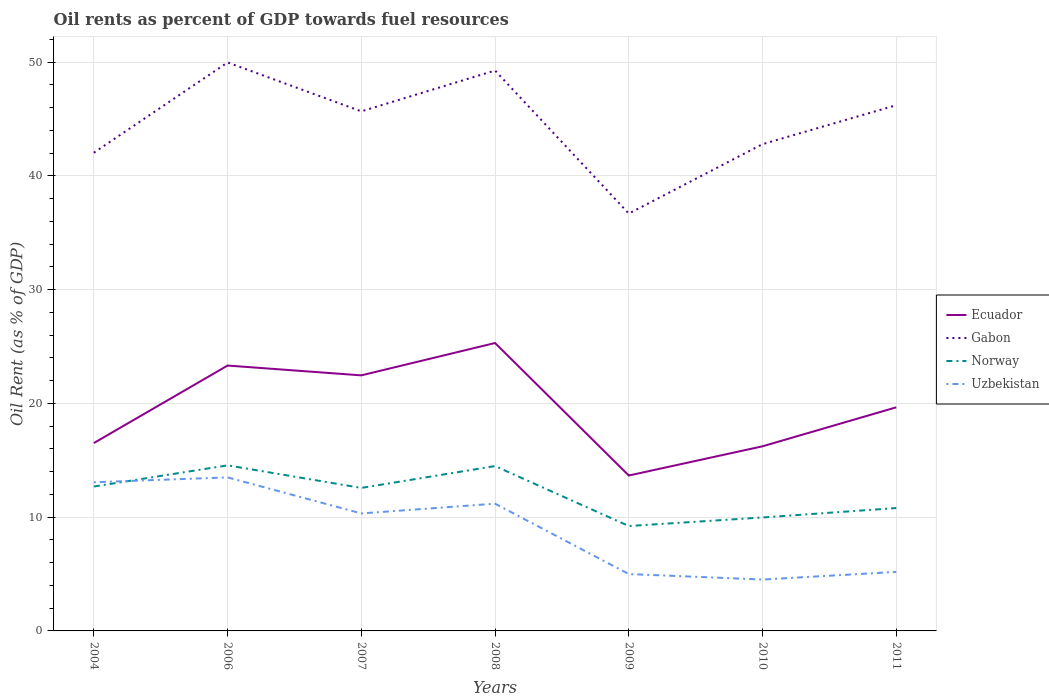Does the line corresponding to Norway intersect with the line corresponding to Uzbekistan?
Keep it short and to the point. Yes. Is the number of lines equal to the number of legend labels?
Ensure brevity in your answer.  Yes. Across all years, what is the maximum oil rent in Gabon?
Keep it short and to the point. 36.69. What is the total oil rent in Norway in the graph?
Provide a short and direct response. 0.12. What is the difference between the highest and the second highest oil rent in Ecuador?
Your answer should be compact. 11.65. How many years are there in the graph?
Your answer should be compact. 7. Does the graph contain any zero values?
Your answer should be compact. No. How many legend labels are there?
Provide a succinct answer. 4. What is the title of the graph?
Give a very brief answer. Oil rents as percent of GDP towards fuel resources. What is the label or title of the Y-axis?
Your response must be concise. Oil Rent (as % of GDP). What is the Oil Rent (as % of GDP) of Ecuador in 2004?
Provide a succinct answer. 16.51. What is the Oil Rent (as % of GDP) of Gabon in 2004?
Your answer should be compact. 42.04. What is the Oil Rent (as % of GDP) in Norway in 2004?
Offer a very short reply. 12.69. What is the Oil Rent (as % of GDP) in Uzbekistan in 2004?
Your answer should be very brief. 13.07. What is the Oil Rent (as % of GDP) of Ecuador in 2006?
Offer a terse response. 23.33. What is the Oil Rent (as % of GDP) of Gabon in 2006?
Ensure brevity in your answer.  49.98. What is the Oil Rent (as % of GDP) of Norway in 2006?
Provide a short and direct response. 14.56. What is the Oil Rent (as % of GDP) of Uzbekistan in 2006?
Provide a succinct answer. 13.5. What is the Oil Rent (as % of GDP) in Ecuador in 2007?
Provide a short and direct response. 22.47. What is the Oil Rent (as % of GDP) in Gabon in 2007?
Your answer should be very brief. 45.68. What is the Oil Rent (as % of GDP) of Norway in 2007?
Make the answer very short. 12.57. What is the Oil Rent (as % of GDP) in Uzbekistan in 2007?
Keep it short and to the point. 10.33. What is the Oil Rent (as % of GDP) of Ecuador in 2008?
Give a very brief answer. 25.31. What is the Oil Rent (as % of GDP) in Gabon in 2008?
Provide a succinct answer. 49.26. What is the Oil Rent (as % of GDP) in Norway in 2008?
Offer a very short reply. 14.49. What is the Oil Rent (as % of GDP) of Uzbekistan in 2008?
Give a very brief answer. 11.19. What is the Oil Rent (as % of GDP) of Ecuador in 2009?
Offer a very short reply. 13.66. What is the Oil Rent (as % of GDP) of Gabon in 2009?
Give a very brief answer. 36.69. What is the Oil Rent (as % of GDP) of Norway in 2009?
Offer a terse response. 9.22. What is the Oil Rent (as % of GDP) of Uzbekistan in 2009?
Your answer should be very brief. 5. What is the Oil Rent (as % of GDP) in Ecuador in 2010?
Give a very brief answer. 16.23. What is the Oil Rent (as % of GDP) of Gabon in 2010?
Provide a short and direct response. 42.79. What is the Oil Rent (as % of GDP) of Norway in 2010?
Make the answer very short. 9.97. What is the Oil Rent (as % of GDP) of Uzbekistan in 2010?
Your response must be concise. 4.52. What is the Oil Rent (as % of GDP) in Ecuador in 2011?
Give a very brief answer. 19.66. What is the Oil Rent (as % of GDP) of Gabon in 2011?
Offer a terse response. 46.22. What is the Oil Rent (as % of GDP) in Norway in 2011?
Offer a terse response. 10.8. What is the Oil Rent (as % of GDP) in Uzbekistan in 2011?
Keep it short and to the point. 5.19. Across all years, what is the maximum Oil Rent (as % of GDP) of Ecuador?
Keep it short and to the point. 25.31. Across all years, what is the maximum Oil Rent (as % of GDP) in Gabon?
Your answer should be very brief. 49.98. Across all years, what is the maximum Oil Rent (as % of GDP) in Norway?
Give a very brief answer. 14.56. Across all years, what is the maximum Oil Rent (as % of GDP) in Uzbekistan?
Your answer should be very brief. 13.5. Across all years, what is the minimum Oil Rent (as % of GDP) of Ecuador?
Provide a succinct answer. 13.66. Across all years, what is the minimum Oil Rent (as % of GDP) of Gabon?
Your answer should be very brief. 36.69. Across all years, what is the minimum Oil Rent (as % of GDP) of Norway?
Offer a very short reply. 9.22. Across all years, what is the minimum Oil Rent (as % of GDP) of Uzbekistan?
Keep it short and to the point. 4.52. What is the total Oil Rent (as % of GDP) in Ecuador in the graph?
Offer a terse response. 137.17. What is the total Oil Rent (as % of GDP) of Gabon in the graph?
Your answer should be very brief. 312.66. What is the total Oil Rent (as % of GDP) in Norway in the graph?
Your answer should be compact. 84.31. What is the total Oil Rent (as % of GDP) of Uzbekistan in the graph?
Ensure brevity in your answer.  62.79. What is the difference between the Oil Rent (as % of GDP) of Ecuador in 2004 and that in 2006?
Ensure brevity in your answer.  -6.82. What is the difference between the Oil Rent (as % of GDP) in Gabon in 2004 and that in 2006?
Make the answer very short. -7.94. What is the difference between the Oil Rent (as % of GDP) of Norway in 2004 and that in 2006?
Provide a succinct answer. -1.86. What is the difference between the Oil Rent (as % of GDP) of Uzbekistan in 2004 and that in 2006?
Offer a terse response. -0.43. What is the difference between the Oil Rent (as % of GDP) of Ecuador in 2004 and that in 2007?
Provide a short and direct response. -5.95. What is the difference between the Oil Rent (as % of GDP) in Gabon in 2004 and that in 2007?
Give a very brief answer. -3.64. What is the difference between the Oil Rent (as % of GDP) of Norway in 2004 and that in 2007?
Make the answer very short. 0.12. What is the difference between the Oil Rent (as % of GDP) of Uzbekistan in 2004 and that in 2007?
Offer a very short reply. 2.74. What is the difference between the Oil Rent (as % of GDP) in Ecuador in 2004 and that in 2008?
Ensure brevity in your answer.  -8.8. What is the difference between the Oil Rent (as % of GDP) in Gabon in 2004 and that in 2008?
Your answer should be very brief. -7.23. What is the difference between the Oil Rent (as % of GDP) of Norway in 2004 and that in 2008?
Offer a very short reply. -1.8. What is the difference between the Oil Rent (as % of GDP) of Uzbekistan in 2004 and that in 2008?
Make the answer very short. 1.88. What is the difference between the Oil Rent (as % of GDP) in Ecuador in 2004 and that in 2009?
Your answer should be compact. 2.85. What is the difference between the Oil Rent (as % of GDP) in Gabon in 2004 and that in 2009?
Provide a short and direct response. 5.35. What is the difference between the Oil Rent (as % of GDP) in Norway in 2004 and that in 2009?
Offer a very short reply. 3.47. What is the difference between the Oil Rent (as % of GDP) in Uzbekistan in 2004 and that in 2009?
Ensure brevity in your answer.  8.07. What is the difference between the Oil Rent (as % of GDP) of Ecuador in 2004 and that in 2010?
Your answer should be very brief. 0.28. What is the difference between the Oil Rent (as % of GDP) of Gabon in 2004 and that in 2010?
Your response must be concise. -0.75. What is the difference between the Oil Rent (as % of GDP) of Norway in 2004 and that in 2010?
Give a very brief answer. 2.72. What is the difference between the Oil Rent (as % of GDP) of Uzbekistan in 2004 and that in 2010?
Your answer should be compact. 8.55. What is the difference between the Oil Rent (as % of GDP) in Ecuador in 2004 and that in 2011?
Provide a short and direct response. -3.14. What is the difference between the Oil Rent (as % of GDP) of Gabon in 2004 and that in 2011?
Your answer should be compact. -4.18. What is the difference between the Oil Rent (as % of GDP) of Norway in 2004 and that in 2011?
Provide a short and direct response. 1.89. What is the difference between the Oil Rent (as % of GDP) in Uzbekistan in 2004 and that in 2011?
Make the answer very short. 7.88. What is the difference between the Oil Rent (as % of GDP) in Ecuador in 2006 and that in 2007?
Ensure brevity in your answer.  0.86. What is the difference between the Oil Rent (as % of GDP) in Gabon in 2006 and that in 2007?
Provide a short and direct response. 4.3. What is the difference between the Oil Rent (as % of GDP) in Norway in 2006 and that in 2007?
Provide a succinct answer. 1.98. What is the difference between the Oil Rent (as % of GDP) of Uzbekistan in 2006 and that in 2007?
Keep it short and to the point. 3.17. What is the difference between the Oil Rent (as % of GDP) in Ecuador in 2006 and that in 2008?
Your answer should be compact. -1.98. What is the difference between the Oil Rent (as % of GDP) of Gabon in 2006 and that in 2008?
Make the answer very short. 0.71. What is the difference between the Oil Rent (as % of GDP) of Norway in 2006 and that in 2008?
Your answer should be very brief. 0.06. What is the difference between the Oil Rent (as % of GDP) in Uzbekistan in 2006 and that in 2008?
Ensure brevity in your answer.  2.31. What is the difference between the Oil Rent (as % of GDP) in Ecuador in 2006 and that in 2009?
Offer a very short reply. 9.67. What is the difference between the Oil Rent (as % of GDP) of Gabon in 2006 and that in 2009?
Provide a short and direct response. 13.29. What is the difference between the Oil Rent (as % of GDP) in Norway in 2006 and that in 2009?
Your response must be concise. 5.33. What is the difference between the Oil Rent (as % of GDP) in Uzbekistan in 2006 and that in 2009?
Keep it short and to the point. 8.5. What is the difference between the Oil Rent (as % of GDP) of Ecuador in 2006 and that in 2010?
Offer a terse response. 7.1. What is the difference between the Oil Rent (as % of GDP) in Gabon in 2006 and that in 2010?
Your answer should be compact. 7.18. What is the difference between the Oil Rent (as % of GDP) in Norway in 2006 and that in 2010?
Offer a terse response. 4.58. What is the difference between the Oil Rent (as % of GDP) of Uzbekistan in 2006 and that in 2010?
Your response must be concise. 8.98. What is the difference between the Oil Rent (as % of GDP) of Ecuador in 2006 and that in 2011?
Keep it short and to the point. 3.67. What is the difference between the Oil Rent (as % of GDP) in Gabon in 2006 and that in 2011?
Provide a short and direct response. 3.76. What is the difference between the Oil Rent (as % of GDP) in Norway in 2006 and that in 2011?
Give a very brief answer. 3.75. What is the difference between the Oil Rent (as % of GDP) in Uzbekistan in 2006 and that in 2011?
Your answer should be compact. 8.31. What is the difference between the Oil Rent (as % of GDP) in Ecuador in 2007 and that in 2008?
Keep it short and to the point. -2.84. What is the difference between the Oil Rent (as % of GDP) in Gabon in 2007 and that in 2008?
Your response must be concise. -3.59. What is the difference between the Oil Rent (as % of GDP) in Norway in 2007 and that in 2008?
Keep it short and to the point. -1.92. What is the difference between the Oil Rent (as % of GDP) of Uzbekistan in 2007 and that in 2008?
Your response must be concise. -0.86. What is the difference between the Oil Rent (as % of GDP) in Ecuador in 2007 and that in 2009?
Offer a very short reply. 8.81. What is the difference between the Oil Rent (as % of GDP) of Gabon in 2007 and that in 2009?
Ensure brevity in your answer.  8.99. What is the difference between the Oil Rent (as % of GDP) in Norway in 2007 and that in 2009?
Your answer should be very brief. 3.35. What is the difference between the Oil Rent (as % of GDP) in Uzbekistan in 2007 and that in 2009?
Offer a very short reply. 5.33. What is the difference between the Oil Rent (as % of GDP) of Ecuador in 2007 and that in 2010?
Your response must be concise. 6.24. What is the difference between the Oil Rent (as % of GDP) in Gabon in 2007 and that in 2010?
Provide a short and direct response. 2.88. What is the difference between the Oil Rent (as % of GDP) of Norway in 2007 and that in 2010?
Ensure brevity in your answer.  2.6. What is the difference between the Oil Rent (as % of GDP) in Uzbekistan in 2007 and that in 2010?
Make the answer very short. 5.81. What is the difference between the Oil Rent (as % of GDP) of Ecuador in 2007 and that in 2011?
Ensure brevity in your answer.  2.81. What is the difference between the Oil Rent (as % of GDP) of Gabon in 2007 and that in 2011?
Make the answer very short. -0.54. What is the difference between the Oil Rent (as % of GDP) of Norway in 2007 and that in 2011?
Ensure brevity in your answer.  1.77. What is the difference between the Oil Rent (as % of GDP) in Uzbekistan in 2007 and that in 2011?
Give a very brief answer. 5.14. What is the difference between the Oil Rent (as % of GDP) of Ecuador in 2008 and that in 2009?
Ensure brevity in your answer.  11.65. What is the difference between the Oil Rent (as % of GDP) in Gabon in 2008 and that in 2009?
Provide a short and direct response. 12.57. What is the difference between the Oil Rent (as % of GDP) in Norway in 2008 and that in 2009?
Provide a succinct answer. 5.27. What is the difference between the Oil Rent (as % of GDP) of Uzbekistan in 2008 and that in 2009?
Make the answer very short. 6.19. What is the difference between the Oil Rent (as % of GDP) in Ecuador in 2008 and that in 2010?
Your answer should be very brief. 9.08. What is the difference between the Oil Rent (as % of GDP) in Gabon in 2008 and that in 2010?
Ensure brevity in your answer.  6.47. What is the difference between the Oil Rent (as % of GDP) of Norway in 2008 and that in 2010?
Your response must be concise. 4.52. What is the difference between the Oil Rent (as % of GDP) of Uzbekistan in 2008 and that in 2010?
Keep it short and to the point. 6.67. What is the difference between the Oil Rent (as % of GDP) of Ecuador in 2008 and that in 2011?
Give a very brief answer. 5.65. What is the difference between the Oil Rent (as % of GDP) in Gabon in 2008 and that in 2011?
Your answer should be compact. 3.05. What is the difference between the Oil Rent (as % of GDP) of Norway in 2008 and that in 2011?
Provide a succinct answer. 3.69. What is the difference between the Oil Rent (as % of GDP) in Uzbekistan in 2008 and that in 2011?
Make the answer very short. 6. What is the difference between the Oil Rent (as % of GDP) in Ecuador in 2009 and that in 2010?
Make the answer very short. -2.57. What is the difference between the Oil Rent (as % of GDP) in Gabon in 2009 and that in 2010?
Keep it short and to the point. -6.1. What is the difference between the Oil Rent (as % of GDP) in Norway in 2009 and that in 2010?
Provide a succinct answer. -0.75. What is the difference between the Oil Rent (as % of GDP) in Uzbekistan in 2009 and that in 2010?
Offer a very short reply. 0.48. What is the difference between the Oil Rent (as % of GDP) in Ecuador in 2009 and that in 2011?
Your answer should be very brief. -6. What is the difference between the Oil Rent (as % of GDP) of Gabon in 2009 and that in 2011?
Make the answer very short. -9.53. What is the difference between the Oil Rent (as % of GDP) in Norway in 2009 and that in 2011?
Keep it short and to the point. -1.58. What is the difference between the Oil Rent (as % of GDP) of Uzbekistan in 2009 and that in 2011?
Your answer should be compact. -0.19. What is the difference between the Oil Rent (as % of GDP) in Ecuador in 2010 and that in 2011?
Offer a very short reply. -3.43. What is the difference between the Oil Rent (as % of GDP) of Gabon in 2010 and that in 2011?
Make the answer very short. -3.42. What is the difference between the Oil Rent (as % of GDP) of Norway in 2010 and that in 2011?
Ensure brevity in your answer.  -0.83. What is the difference between the Oil Rent (as % of GDP) in Uzbekistan in 2010 and that in 2011?
Provide a succinct answer. -0.67. What is the difference between the Oil Rent (as % of GDP) of Ecuador in 2004 and the Oil Rent (as % of GDP) of Gabon in 2006?
Your answer should be very brief. -33.46. What is the difference between the Oil Rent (as % of GDP) of Ecuador in 2004 and the Oil Rent (as % of GDP) of Norway in 2006?
Give a very brief answer. 1.96. What is the difference between the Oil Rent (as % of GDP) of Ecuador in 2004 and the Oil Rent (as % of GDP) of Uzbekistan in 2006?
Provide a short and direct response. 3.02. What is the difference between the Oil Rent (as % of GDP) in Gabon in 2004 and the Oil Rent (as % of GDP) in Norway in 2006?
Give a very brief answer. 27.48. What is the difference between the Oil Rent (as % of GDP) in Gabon in 2004 and the Oil Rent (as % of GDP) in Uzbekistan in 2006?
Make the answer very short. 28.54. What is the difference between the Oil Rent (as % of GDP) of Norway in 2004 and the Oil Rent (as % of GDP) of Uzbekistan in 2006?
Your answer should be very brief. -0.8. What is the difference between the Oil Rent (as % of GDP) in Ecuador in 2004 and the Oil Rent (as % of GDP) in Gabon in 2007?
Make the answer very short. -29.16. What is the difference between the Oil Rent (as % of GDP) of Ecuador in 2004 and the Oil Rent (as % of GDP) of Norway in 2007?
Your answer should be very brief. 3.94. What is the difference between the Oil Rent (as % of GDP) of Ecuador in 2004 and the Oil Rent (as % of GDP) of Uzbekistan in 2007?
Your answer should be very brief. 6.19. What is the difference between the Oil Rent (as % of GDP) of Gabon in 2004 and the Oil Rent (as % of GDP) of Norway in 2007?
Your answer should be very brief. 29.47. What is the difference between the Oil Rent (as % of GDP) of Gabon in 2004 and the Oil Rent (as % of GDP) of Uzbekistan in 2007?
Keep it short and to the point. 31.71. What is the difference between the Oil Rent (as % of GDP) in Norway in 2004 and the Oil Rent (as % of GDP) in Uzbekistan in 2007?
Your answer should be very brief. 2.37. What is the difference between the Oil Rent (as % of GDP) of Ecuador in 2004 and the Oil Rent (as % of GDP) of Gabon in 2008?
Your response must be concise. -32.75. What is the difference between the Oil Rent (as % of GDP) of Ecuador in 2004 and the Oil Rent (as % of GDP) of Norway in 2008?
Ensure brevity in your answer.  2.02. What is the difference between the Oil Rent (as % of GDP) of Ecuador in 2004 and the Oil Rent (as % of GDP) of Uzbekistan in 2008?
Your answer should be very brief. 5.33. What is the difference between the Oil Rent (as % of GDP) of Gabon in 2004 and the Oil Rent (as % of GDP) of Norway in 2008?
Give a very brief answer. 27.55. What is the difference between the Oil Rent (as % of GDP) in Gabon in 2004 and the Oil Rent (as % of GDP) in Uzbekistan in 2008?
Provide a succinct answer. 30.85. What is the difference between the Oil Rent (as % of GDP) of Norway in 2004 and the Oil Rent (as % of GDP) of Uzbekistan in 2008?
Your response must be concise. 1.51. What is the difference between the Oil Rent (as % of GDP) in Ecuador in 2004 and the Oil Rent (as % of GDP) in Gabon in 2009?
Offer a terse response. -20.18. What is the difference between the Oil Rent (as % of GDP) of Ecuador in 2004 and the Oil Rent (as % of GDP) of Norway in 2009?
Offer a very short reply. 7.29. What is the difference between the Oil Rent (as % of GDP) of Ecuador in 2004 and the Oil Rent (as % of GDP) of Uzbekistan in 2009?
Provide a short and direct response. 11.51. What is the difference between the Oil Rent (as % of GDP) in Gabon in 2004 and the Oil Rent (as % of GDP) in Norway in 2009?
Provide a succinct answer. 32.82. What is the difference between the Oil Rent (as % of GDP) in Gabon in 2004 and the Oil Rent (as % of GDP) in Uzbekistan in 2009?
Your answer should be compact. 37.04. What is the difference between the Oil Rent (as % of GDP) in Norway in 2004 and the Oil Rent (as % of GDP) in Uzbekistan in 2009?
Your response must be concise. 7.69. What is the difference between the Oil Rent (as % of GDP) in Ecuador in 2004 and the Oil Rent (as % of GDP) in Gabon in 2010?
Your answer should be compact. -26.28. What is the difference between the Oil Rent (as % of GDP) in Ecuador in 2004 and the Oil Rent (as % of GDP) in Norway in 2010?
Your answer should be very brief. 6.54. What is the difference between the Oil Rent (as % of GDP) in Ecuador in 2004 and the Oil Rent (as % of GDP) in Uzbekistan in 2010?
Give a very brief answer. 12. What is the difference between the Oil Rent (as % of GDP) of Gabon in 2004 and the Oil Rent (as % of GDP) of Norway in 2010?
Ensure brevity in your answer.  32.07. What is the difference between the Oil Rent (as % of GDP) of Gabon in 2004 and the Oil Rent (as % of GDP) of Uzbekistan in 2010?
Give a very brief answer. 37.52. What is the difference between the Oil Rent (as % of GDP) in Norway in 2004 and the Oil Rent (as % of GDP) in Uzbekistan in 2010?
Your response must be concise. 8.18. What is the difference between the Oil Rent (as % of GDP) of Ecuador in 2004 and the Oil Rent (as % of GDP) of Gabon in 2011?
Your response must be concise. -29.7. What is the difference between the Oil Rent (as % of GDP) in Ecuador in 2004 and the Oil Rent (as % of GDP) in Norway in 2011?
Keep it short and to the point. 5.71. What is the difference between the Oil Rent (as % of GDP) of Ecuador in 2004 and the Oil Rent (as % of GDP) of Uzbekistan in 2011?
Provide a succinct answer. 11.33. What is the difference between the Oil Rent (as % of GDP) of Gabon in 2004 and the Oil Rent (as % of GDP) of Norway in 2011?
Make the answer very short. 31.24. What is the difference between the Oil Rent (as % of GDP) of Gabon in 2004 and the Oil Rent (as % of GDP) of Uzbekistan in 2011?
Ensure brevity in your answer.  36.85. What is the difference between the Oil Rent (as % of GDP) of Norway in 2004 and the Oil Rent (as % of GDP) of Uzbekistan in 2011?
Make the answer very short. 7.5. What is the difference between the Oil Rent (as % of GDP) in Ecuador in 2006 and the Oil Rent (as % of GDP) in Gabon in 2007?
Offer a very short reply. -22.35. What is the difference between the Oil Rent (as % of GDP) of Ecuador in 2006 and the Oil Rent (as % of GDP) of Norway in 2007?
Offer a very short reply. 10.76. What is the difference between the Oil Rent (as % of GDP) in Ecuador in 2006 and the Oil Rent (as % of GDP) in Uzbekistan in 2007?
Provide a succinct answer. 13. What is the difference between the Oil Rent (as % of GDP) of Gabon in 2006 and the Oil Rent (as % of GDP) of Norway in 2007?
Provide a short and direct response. 37.41. What is the difference between the Oil Rent (as % of GDP) of Gabon in 2006 and the Oil Rent (as % of GDP) of Uzbekistan in 2007?
Offer a terse response. 39.65. What is the difference between the Oil Rent (as % of GDP) in Norway in 2006 and the Oil Rent (as % of GDP) in Uzbekistan in 2007?
Ensure brevity in your answer.  4.23. What is the difference between the Oil Rent (as % of GDP) in Ecuador in 2006 and the Oil Rent (as % of GDP) in Gabon in 2008?
Your answer should be very brief. -25.93. What is the difference between the Oil Rent (as % of GDP) in Ecuador in 2006 and the Oil Rent (as % of GDP) in Norway in 2008?
Make the answer very short. 8.84. What is the difference between the Oil Rent (as % of GDP) in Ecuador in 2006 and the Oil Rent (as % of GDP) in Uzbekistan in 2008?
Ensure brevity in your answer.  12.14. What is the difference between the Oil Rent (as % of GDP) in Gabon in 2006 and the Oil Rent (as % of GDP) in Norway in 2008?
Make the answer very short. 35.48. What is the difference between the Oil Rent (as % of GDP) of Gabon in 2006 and the Oil Rent (as % of GDP) of Uzbekistan in 2008?
Make the answer very short. 38.79. What is the difference between the Oil Rent (as % of GDP) in Norway in 2006 and the Oil Rent (as % of GDP) in Uzbekistan in 2008?
Give a very brief answer. 3.37. What is the difference between the Oil Rent (as % of GDP) of Ecuador in 2006 and the Oil Rent (as % of GDP) of Gabon in 2009?
Offer a very short reply. -13.36. What is the difference between the Oil Rent (as % of GDP) in Ecuador in 2006 and the Oil Rent (as % of GDP) in Norway in 2009?
Make the answer very short. 14.11. What is the difference between the Oil Rent (as % of GDP) in Ecuador in 2006 and the Oil Rent (as % of GDP) in Uzbekistan in 2009?
Your answer should be compact. 18.33. What is the difference between the Oil Rent (as % of GDP) in Gabon in 2006 and the Oil Rent (as % of GDP) in Norway in 2009?
Your response must be concise. 40.76. What is the difference between the Oil Rent (as % of GDP) of Gabon in 2006 and the Oil Rent (as % of GDP) of Uzbekistan in 2009?
Give a very brief answer. 44.98. What is the difference between the Oil Rent (as % of GDP) of Norway in 2006 and the Oil Rent (as % of GDP) of Uzbekistan in 2009?
Your response must be concise. 9.56. What is the difference between the Oil Rent (as % of GDP) in Ecuador in 2006 and the Oil Rent (as % of GDP) in Gabon in 2010?
Your answer should be very brief. -19.46. What is the difference between the Oil Rent (as % of GDP) in Ecuador in 2006 and the Oil Rent (as % of GDP) in Norway in 2010?
Keep it short and to the point. 13.36. What is the difference between the Oil Rent (as % of GDP) of Ecuador in 2006 and the Oil Rent (as % of GDP) of Uzbekistan in 2010?
Your answer should be very brief. 18.81. What is the difference between the Oil Rent (as % of GDP) in Gabon in 2006 and the Oil Rent (as % of GDP) in Norway in 2010?
Your response must be concise. 40. What is the difference between the Oil Rent (as % of GDP) in Gabon in 2006 and the Oil Rent (as % of GDP) in Uzbekistan in 2010?
Keep it short and to the point. 45.46. What is the difference between the Oil Rent (as % of GDP) of Norway in 2006 and the Oil Rent (as % of GDP) of Uzbekistan in 2010?
Your response must be concise. 10.04. What is the difference between the Oil Rent (as % of GDP) of Ecuador in 2006 and the Oil Rent (as % of GDP) of Gabon in 2011?
Provide a short and direct response. -22.89. What is the difference between the Oil Rent (as % of GDP) of Ecuador in 2006 and the Oil Rent (as % of GDP) of Norway in 2011?
Keep it short and to the point. 12.53. What is the difference between the Oil Rent (as % of GDP) of Ecuador in 2006 and the Oil Rent (as % of GDP) of Uzbekistan in 2011?
Make the answer very short. 18.14. What is the difference between the Oil Rent (as % of GDP) of Gabon in 2006 and the Oil Rent (as % of GDP) of Norway in 2011?
Your response must be concise. 39.17. What is the difference between the Oil Rent (as % of GDP) of Gabon in 2006 and the Oil Rent (as % of GDP) of Uzbekistan in 2011?
Provide a short and direct response. 44.79. What is the difference between the Oil Rent (as % of GDP) in Norway in 2006 and the Oil Rent (as % of GDP) in Uzbekistan in 2011?
Keep it short and to the point. 9.37. What is the difference between the Oil Rent (as % of GDP) in Ecuador in 2007 and the Oil Rent (as % of GDP) in Gabon in 2008?
Offer a very short reply. -26.8. What is the difference between the Oil Rent (as % of GDP) in Ecuador in 2007 and the Oil Rent (as % of GDP) in Norway in 2008?
Provide a succinct answer. 7.97. What is the difference between the Oil Rent (as % of GDP) in Ecuador in 2007 and the Oil Rent (as % of GDP) in Uzbekistan in 2008?
Ensure brevity in your answer.  11.28. What is the difference between the Oil Rent (as % of GDP) in Gabon in 2007 and the Oil Rent (as % of GDP) in Norway in 2008?
Your answer should be very brief. 31.18. What is the difference between the Oil Rent (as % of GDP) of Gabon in 2007 and the Oil Rent (as % of GDP) of Uzbekistan in 2008?
Your response must be concise. 34.49. What is the difference between the Oil Rent (as % of GDP) in Norway in 2007 and the Oil Rent (as % of GDP) in Uzbekistan in 2008?
Provide a short and direct response. 1.39. What is the difference between the Oil Rent (as % of GDP) in Ecuador in 2007 and the Oil Rent (as % of GDP) in Gabon in 2009?
Offer a very short reply. -14.22. What is the difference between the Oil Rent (as % of GDP) in Ecuador in 2007 and the Oil Rent (as % of GDP) in Norway in 2009?
Your answer should be compact. 13.25. What is the difference between the Oil Rent (as % of GDP) in Ecuador in 2007 and the Oil Rent (as % of GDP) in Uzbekistan in 2009?
Offer a very short reply. 17.47. What is the difference between the Oil Rent (as % of GDP) of Gabon in 2007 and the Oil Rent (as % of GDP) of Norway in 2009?
Make the answer very short. 36.46. What is the difference between the Oil Rent (as % of GDP) of Gabon in 2007 and the Oil Rent (as % of GDP) of Uzbekistan in 2009?
Your answer should be very brief. 40.68. What is the difference between the Oil Rent (as % of GDP) of Norway in 2007 and the Oil Rent (as % of GDP) of Uzbekistan in 2009?
Your response must be concise. 7.57. What is the difference between the Oil Rent (as % of GDP) in Ecuador in 2007 and the Oil Rent (as % of GDP) in Gabon in 2010?
Your response must be concise. -20.33. What is the difference between the Oil Rent (as % of GDP) in Ecuador in 2007 and the Oil Rent (as % of GDP) in Norway in 2010?
Your answer should be compact. 12.49. What is the difference between the Oil Rent (as % of GDP) of Ecuador in 2007 and the Oil Rent (as % of GDP) of Uzbekistan in 2010?
Offer a terse response. 17.95. What is the difference between the Oil Rent (as % of GDP) of Gabon in 2007 and the Oil Rent (as % of GDP) of Norway in 2010?
Your answer should be very brief. 35.7. What is the difference between the Oil Rent (as % of GDP) of Gabon in 2007 and the Oil Rent (as % of GDP) of Uzbekistan in 2010?
Give a very brief answer. 41.16. What is the difference between the Oil Rent (as % of GDP) of Norway in 2007 and the Oil Rent (as % of GDP) of Uzbekistan in 2010?
Make the answer very short. 8.05. What is the difference between the Oil Rent (as % of GDP) in Ecuador in 2007 and the Oil Rent (as % of GDP) in Gabon in 2011?
Offer a terse response. -23.75. What is the difference between the Oil Rent (as % of GDP) of Ecuador in 2007 and the Oil Rent (as % of GDP) of Norway in 2011?
Your answer should be very brief. 11.66. What is the difference between the Oil Rent (as % of GDP) of Ecuador in 2007 and the Oil Rent (as % of GDP) of Uzbekistan in 2011?
Give a very brief answer. 17.28. What is the difference between the Oil Rent (as % of GDP) in Gabon in 2007 and the Oil Rent (as % of GDP) in Norway in 2011?
Make the answer very short. 34.87. What is the difference between the Oil Rent (as % of GDP) in Gabon in 2007 and the Oil Rent (as % of GDP) in Uzbekistan in 2011?
Provide a succinct answer. 40.49. What is the difference between the Oil Rent (as % of GDP) of Norway in 2007 and the Oil Rent (as % of GDP) of Uzbekistan in 2011?
Ensure brevity in your answer.  7.38. What is the difference between the Oil Rent (as % of GDP) of Ecuador in 2008 and the Oil Rent (as % of GDP) of Gabon in 2009?
Your answer should be compact. -11.38. What is the difference between the Oil Rent (as % of GDP) of Ecuador in 2008 and the Oil Rent (as % of GDP) of Norway in 2009?
Offer a very short reply. 16.09. What is the difference between the Oil Rent (as % of GDP) in Ecuador in 2008 and the Oil Rent (as % of GDP) in Uzbekistan in 2009?
Give a very brief answer. 20.31. What is the difference between the Oil Rent (as % of GDP) of Gabon in 2008 and the Oil Rent (as % of GDP) of Norway in 2009?
Give a very brief answer. 40.04. What is the difference between the Oil Rent (as % of GDP) of Gabon in 2008 and the Oil Rent (as % of GDP) of Uzbekistan in 2009?
Your answer should be very brief. 44.26. What is the difference between the Oil Rent (as % of GDP) of Norway in 2008 and the Oil Rent (as % of GDP) of Uzbekistan in 2009?
Provide a short and direct response. 9.49. What is the difference between the Oil Rent (as % of GDP) in Ecuador in 2008 and the Oil Rent (as % of GDP) in Gabon in 2010?
Your answer should be very brief. -17.48. What is the difference between the Oil Rent (as % of GDP) in Ecuador in 2008 and the Oil Rent (as % of GDP) in Norway in 2010?
Your answer should be compact. 15.34. What is the difference between the Oil Rent (as % of GDP) in Ecuador in 2008 and the Oil Rent (as % of GDP) in Uzbekistan in 2010?
Your answer should be compact. 20.79. What is the difference between the Oil Rent (as % of GDP) in Gabon in 2008 and the Oil Rent (as % of GDP) in Norway in 2010?
Give a very brief answer. 39.29. What is the difference between the Oil Rent (as % of GDP) in Gabon in 2008 and the Oil Rent (as % of GDP) in Uzbekistan in 2010?
Ensure brevity in your answer.  44.75. What is the difference between the Oil Rent (as % of GDP) of Norway in 2008 and the Oil Rent (as % of GDP) of Uzbekistan in 2010?
Provide a short and direct response. 9.98. What is the difference between the Oil Rent (as % of GDP) of Ecuador in 2008 and the Oil Rent (as % of GDP) of Gabon in 2011?
Offer a very short reply. -20.91. What is the difference between the Oil Rent (as % of GDP) of Ecuador in 2008 and the Oil Rent (as % of GDP) of Norway in 2011?
Give a very brief answer. 14.51. What is the difference between the Oil Rent (as % of GDP) of Ecuador in 2008 and the Oil Rent (as % of GDP) of Uzbekistan in 2011?
Make the answer very short. 20.12. What is the difference between the Oil Rent (as % of GDP) in Gabon in 2008 and the Oil Rent (as % of GDP) in Norway in 2011?
Provide a succinct answer. 38.46. What is the difference between the Oil Rent (as % of GDP) of Gabon in 2008 and the Oil Rent (as % of GDP) of Uzbekistan in 2011?
Your response must be concise. 44.08. What is the difference between the Oil Rent (as % of GDP) in Norway in 2008 and the Oil Rent (as % of GDP) in Uzbekistan in 2011?
Provide a short and direct response. 9.3. What is the difference between the Oil Rent (as % of GDP) in Ecuador in 2009 and the Oil Rent (as % of GDP) in Gabon in 2010?
Keep it short and to the point. -29.13. What is the difference between the Oil Rent (as % of GDP) of Ecuador in 2009 and the Oil Rent (as % of GDP) of Norway in 2010?
Provide a succinct answer. 3.69. What is the difference between the Oil Rent (as % of GDP) in Ecuador in 2009 and the Oil Rent (as % of GDP) in Uzbekistan in 2010?
Your answer should be compact. 9.14. What is the difference between the Oil Rent (as % of GDP) of Gabon in 2009 and the Oil Rent (as % of GDP) of Norway in 2010?
Ensure brevity in your answer.  26.72. What is the difference between the Oil Rent (as % of GDP) of Gabon in 2009 and the Oil Rent (as % of GDP) of Uzbekistan in 2010?
Offer a very short reply. 32.17. What is the difference between the Oil Rent (as % of GDP) in Norway in 2009 and the Oil Rent (as % of GDP) in Uzbekistan in 2010?
Offer a terse response. 4.7. What is the difference between the Oil Rent (as % of GDP) in Ecuador in 2009 and the Oil Rent (as % of GDP) in Gabon in 2011?
Ensure brevity in your answer.  -32.56. What is the difference between the Oil Rent (as % of GDP) of Ecuador in 2009 and the Oil Rent (as % of GDP) of Norway in 2011?
Your answer should be compact. 2.86. What is the difference between the Oil Rent (as % of GDP) of Ecuador in 2009 and the Oil Rent (as % of GDP) of Uzbekistan in 2011?
Offer a very short reply. 8.47. What is the difference between the Oil Rent (as % of GDP) in Gabon in 2009 and the Oil Rent (as % of GDP) in Norway in 2011?
Provide a short and direct response. 25.89. What is the difference between the Oil Rent (as % of GDP) of Gabon in 2009 and the Oil Rent (as % of GDP) of Uzbekistan in 2011?
Your answer should be very brief. 31.5. What is the difference between the Oil Rent (as % of GDP) in Norway in 2009 and the Oil Rent (as % of GDP) in Uzbekistan in 2011?
Your answer should be compact. 4.03. What is the difference between the Oil Rent (as % of GDP) of Ecuador in 2010 and the Oil Rent (as % of GDP) of Gabon in 2011?
Provide a succinct answer. -29.99. What is the difference between the Oil Rent (as % of GDP) in Ecuador in 2010 and the Oil Rent (as % of GDP) in Norway in 2011?
Your answer should be very brief. 5.43. What is the difference between the Oil Rent (as % of GDP) in Ecuador in 2010 and the Oil Rent (as % of GDP) in Uzbekistan in 2011?
Your answer should be compact. 11.04. What is the difference between the Oil Rent (as % of GDP) of Gabon in 2010 and the Oil Rent (as % of GDP) of Norway in 2011?
Give a very brief answer. 31.99. What is the difference between the Oil Rent (as % of GDP) in Gabon in 2010 and the Oil Rent (as % of GDP) in Uzbekistan in 2011?
Offer a terse response. 37.6. What is the difference between the Oil Rent (as % of GDP) of Norway in 2010 and the Oil Rent (as % of GDP) of Uzbekistan in 2011?
Keep it short and to the point. 4.78. What is the average Oil Rent (as % of GDP) in Ecuador per year?
Provide a short and direct response. 19.6. What is the average Oil Rent (as % of GDP) in Gabon per year?
Make the answer very short. 44.67. What is the average Oil Rent (as % of GDP) in Norway per year?
Your answer should be very brief. 12.04. What is the average Oil Rent (as % of GDP) of Uzbekistan per year?
Make the answer very short. 8.97. In the year 2004, what is the difference between the Oil Rent (as % of GDP) of Ecuador and Oil Rent (as % of GDP) of Gabon?
Give a very brief answer. -25.52. In the year 2004, what is the difference between the Oil Rent (as % of GDP) in Ecuador and Oil Rent (as % of GDP) in Norway?
Offer a terse response. 3.82. In the year 2004, what is the difference between the Oil Rent (as % of GDP) of Ecuador and Oil Rent (as % of GDP) of Uzbekistan?
Your response must be concise. 3.45. In the year 2004, what is the difference between the Oil Rent (as % of GDP) in Gabon and Oil Rent (as % of GDP) in Norway?
Provide a succinct answer. 29.34. In the year 2004, what is the difference between the Oil Rent (as % of GDP) in Gabon and Oil Rent (as % of GDP) in Uzbekistan?
Provide a succinct answer. 28.97. In the year 2004, what is the difference between the Oil Rent (as % of GDP) in Norway and Oil Rent (as % of GDP) in Uzbekistan?
Give a very brief answer. -0.37. In the year 2006, what is the difference between the Oil Rent (as % of GDP) of Ecuador and Oil Rent (as % of GDP) of Gabon?
Provide a succinct answer. -26.65. In the year 2006, what is the difference between the Oil Rent (as % of GDP) in Ecuador and Oil Rent (as % of GDP) in Norway?
Offer a terse response. 8.77. In the year 2006, what is the difference between the Oil Rent (as % of GDP) of Ecuador and Oil Rent (as % of GDP) of Uzbekistan?
Your answer should be very brief. 9.83. In the year 2006, what is the difference between the Oil Rent (as % of GDP) of Gabon and Oil Rent (as % of GDP) of Norway?
Keep it short and to the point. 35.42. In the year 2006, what is the difference between the Oil Rent (as % of GDP) in Gabon and Oil Rent (as % of GDP) in Uzbekistan?
Your answer should be very brief. 36.48. In the year 2006, what is the difference between the Oil Rent (as % of GDP) in Norway and Oil Rent (as % of GDP) in Uzbekistan?
Keep it short and to the point. 1.06. In the year 2007, what is the difference between the Oil Rent (as % of GDP) in Ecuador and Oil Rent (as % of GDP) in Gabon?
Ensure brevity in your answer.  -23.21. In the year 2007, what is the difference between the Oil Rent (as % of GDP) of Ecuador and Oil Rent (as % of GDP) of Norway?
Ensure brevity in your answer.  9.9. In the year 2007, what is the difference between the Oil Rent (as % of GDP) in Ecuador and Oil Rent (as % of GDP) in Uzbekistan?
Offer a very short reply. 12.14. In the year 2007, what is the difference between the Oil Rent (as % of GDP) of Gabon and Oil Rent (as % of GDP) of Norway?
Your response must be concise. 33.11. In the year 2007, what is the difference between the Oil Rent (as % of GDP) of Gabon and Oil Rent (as % of GDP) of Uzbekistan?
Provide a succinct answer. 35.35. In the year 2007, what is the difference between the Oil Rent (as % of GDP) of Norway and Oil Rent (as % of GDP) of Uzbekistan?
Your answer should be very brief. 2.24. In the year 2008, what is the difference between the Oil Rent (as % of GDP) of Ecuador and Oil Rent (as % of GDP) of Gabon?
Your answer should be very brief. -23.95. In the year 2008, what is the difference between the Oil Rent (as % of GDP) in Ecuador and Oil Rent (as % of GDP) in Norway?
Provide a short and direct response. 10.82. In the year 2008, what is the difference between the Oil Rent (as % of GDP) of Ecuador and Oil Rent (as % of GDP) of Uzbekistan?
Keep it short and to the point. 14.12. In the year 2008, what is the difference between the Oil Rent (as % of GDP) in Gabon and Oil Rent (as % of GDP) in Norway?
Ensure brevity in your answer.  34.77. In the year 2008, what is the difference between the Oil Rent (as % of GDP) of Gabon and Oil Rent (as % of GDP) of Uzbekistan?
Your answer should be compact. 38.08. In the year 2008, what is the difference between the Oil Rent (as % of GDP) in Norway and Oil Rent (as % of GDP) in Uzbekistan?
Your answer should be very brief. 3.31. In the year 2009, what is the difference between the Oil Rent (as % of GDP) in Ecuador and Oil Rent (as % of GDP) in Gabon?
Offer a terse response. -23.03. In the year 2009, what is the difference between the Oil Rent (as % of GDP) of Ecuador and Oil Rent (as % of GDP) of Norway?
Offer a terse response. 4.44. In the year 2009, what is the difference between the Oil Rent (as % of GDP) of Ecuador and Oil Rent (as % of GDP) of Uzbekistan?
Your response must be concise. 8.66. In the year 2009, what is the difference between the Oil Rent (as % of GDP) in Gabon and Oil Rent (as % of GDP) in Norway?
Offer a very short reply. 27.47. In the year 2009, what is the difference between the Oil Rent (as % of GDP) in Gabon and Oil Rent (as % of GDP) in Uzbekistan?
Your answer should be compact. 31.69. In the year 2009, what is the difference between the Oil Rent (as % of GDP) in Norway and Oil Rent (as % of GDP) in Uzbekistan?
Your response must be concise. 4.22. In the year 2010, what is the difference between the Oil Rent (as % of GDP) in Ecuador and Oil Rent (as % of GDP) in Gabon?
Provide a succinct answer. -26.56. In the year 2010, what is the difference between the Oil Rent (as % of GDP) of Ecuador and Oil Rent (as % of GDP) of Norway?
Ensure brevity in your answer.  6.26. In the year 2010, what is the difference between the Oil Rent (as % of GDP) of Ecuador and Oil Rent (as % of GDP) of Uzbekistan?
Provide a succinct answer. 11.71. In the year 2010, what is the difference between the Oil Rent (as % of GDP) of Gabon and Oil Rent (as % of GDP) of Norway?
Offer a very short reply. 32.82. In the year 2010, what is the difference between the Oil Rent (as % of GDP) of Gabon and Oil Rent (as % of GDP) of Uzbekistan?
Your answer should be very brief. 38.28. In the year 2010, what is the difference between the Oil Rent (as % of GDP) in Norway and Oil Rent (as % of GDP) in Uzbekistan?
Ensure brevity in your answer.  5.46. In the year 2011, what is the difference between the Oil Rent (as % of GDP) in Ecuador and Oil Rent (as % of GDP) in Gabon?
Your response must be concise. -26.56. In the year 2011, what is the difference between the Oil Rent (as % of GDP) of Ecuador and Oil Rent (as % of GDP) of Norway?
Provide a short and direct response. 8.85. In the year 2011, what is the difference between the Oil Rent (as % of GDP) in Ecuador and Oil Rent (as % of GDP) in Uzbekistan?
Keep it short and to the point. 14.47. In the year 2011, what is the difference between the Oil Rent (as % of GDP) in Gabon and Oil Rent (as % of GDP) in Norway?
Your answer should be very brief. 35.41. In the year 2011, what is the difference between the Oil Rent (as % of GDP) in Gabon and Oil Rent (as % of GDP) in Uzbekistan?
Keep it short and to the point. 41.03. In the year 2011, what is the difference between the Oil Rent (as % of GDP) of Norway and Oil Rent (as % of GDP) of Uzbekistan?
Offer a very short reply. 5.61. What is the ratio of the Oil Rent (as % of GDP) in Ecuador in 2004 to that in 2006?
Keep it short and to the point. 0.71. What is the ratio of the Oil Rent (as % of GDP) in Gabon in 2004 to that in 2006?
Offer a very short reply. 0.84. What is the ratio of the Oil Rent (as % of GDP) in Norway in 2004 to that in 2006?
Give a very brief answer. 0.87. What is the ratio of the Oil Rent (as % of GDP) of Uzbekistan in 2004 to that in 2006?
Give a very brief answer. 0.97. What is the ratio of the Oil Rent (as % of GDP) of Ecuador in 2004 to that in 2007?
Your response must be concise. 0.74. What is the ratio of the Oil Rent (as % of GDP) in Gabon in 2004 to that in 2007?
Provide a succinct answer. 0.92. What is the ratio of the Oil Rent (as % of GDP) in Norway in 2004 to that in 2007?
Your response must be concise. 1.01. What is the ratio of the Oil Rent (as % of GDP) of Uzbekistan in 2004 to that in 2007?
Give a very brief answer. 1.27. What is the ratio of the Oil Rent (as % of GDP) in Ecuador in 2004 to that in 2008?
Your answer should be compact. 0.65. What is the ratio of the Oil Rent (as % of GDP) in Gabon in 2004 to that in 2008?
Offer a very short reply. 0.85. What is the ratio of the Oil Rent (as % of GDP) of Norway in 2004 to that in 2008?
Your answer should be very brief. 0.88. What is the ratio of the Oil Rent (as % of GDP) in Uzbekistan in 2004 to that in 2008?
Ensure brevity in your answer.  1.17. What is the ratio of the Oil Rent (as % of GDP) of Ecuador in 2004 to that in 2009?
Your answer should be very brief. 1.21. What is the ratio of the Oil Rent (as % of GDP) of Gabon in 2004 to that in 2009?
Your response must be concise. 1.15. What is the ratio of the Oil Rent (as % of GDP) of Norway in 2004 to that in 2009?
Your answer should be very brief. 1.38. What is the ratio of the Oil Rent (as % of GDP) in Uzbekistan in 2004 to that in 2009?
Provide a succinct answer. 2.61. What is the ratio of the Oil Rent (as % of GDP) of Ecuador in 2004 to that in 2010?
Keep it short and to the point. 1.02. What is the ratio of the Oil Rent (as % of GDP) of Gabon in 2004 to that in 2010?
Your response must be concise. 0.98. What is the ratio of the Oil Rent (as % of GDP) in Norway in 2004 to that in 2010?
Your response must be concise. 1.27. What is the ratio of the Oil Rent (as % of GDP) in Uzbekistan in 2004 to that in 2010?
Provide a succinct answer. 2.89. What is the ratio of the Oil Rent (as % of GDP) of Ecuador in 2004 to that in 2011?
Offer a terse response. 0.84. What is the ratio of the Oil Rent (as % of GDP) of Gabon in 2004 to that in 2011?
Offer a terse response. 0.91. What is the ratio of the Oil Rent (as % of GDP) in Norway in 2004 to that in 2011?
Make the answer very short. 1.18. What is the ratio of the Oil Rent (as % of GDP) of Uzbekistan in 2004 to that in 2011?
Ensure brevity in your answer.  2.52. What is the ratio of the Oil Rent (as % of GDP) in Ecuador in 2006 to that in 2007?
Your answer should be very brief. 1.04. What is the ratio of the Oil Rent (as % of GDP) in Gabon in 2006 to that in 2007?
Provide a short and direct response. 1.09. What is the ratio of the Oil Rent (as % of GDP) in Norway in 2006 to that in 2007?
Give a very brief answer. 1.16. What is the ratio of the Oil Rent (as % of GDP) of Uzbekistan in 2006 to that in 2007?
Keep it short and to the point. 1.31. What is the ratio of the Oil Rent (as % of GDP) of Ecuador in 2006 to that in 2008?
Keep it short and to the point. 0.92. What is the ratio of the Oil Rent (as % of GDP) in Gabon in 2006 to that in 2008?
Make the answer very short. 1.01. What is the ratio of the Oil Rent (as % of GDP) in Uzbekistan in 2006 to that in 2008?
Your response must be concise. 1.21. What is the ratio of the Oil Rent (as % of GDP) of Ecuador in 2006 to that in 2009?
Your response must be concise. 1.71. What is the ratio of the Oil Rent (as % of GDP) in Gabon in 2006 to that in 2009?
Keep it short and to the point. 1.36. What is the ratio of the Oil Rent (as % of GDP) of Norway in 2006 to that in 2009?
Ensure brevity in your answer.  1.58. What is the ratio of the Oil Rent (as % of GDP) of Uzbekistan in 2006 to that in 2009?
Make the answer very short. 2.7. What is the ratio of the Oil Rent (as % of GDP) of Ecuador in 2006 to that in 2010?
Provide a short and direct response. 1.44. What is the ratio of the Oil Rent (as % of GDP) in Gabon in 2006 to that in 2010?
Offer a terse response. 1.17. What is the ratio of the Oil Rent (as % of GDP) of Norway in 2006 to that in 2010?
Offer a very short reply. 1.46. What is the ratio of the Oil Rent (as % of GDP) in Uzbekistan in 2006 to that in 2010?
Offer a terse response. 2.99. What is the ratio of the Oil Rent (as % of GDP) in Ecuador in 2006 to that in 2011?
Your response must be concise. 1.19. What is the ratio of the Oil Rent (as % of GDP) of Gabon in 2006 to that in 2011?
Your answer should be very brief. 1.08. What is the ratio of the Oil Rent (as % of GDP) in Norway in 2006 to that in 2011?
Keep it short and to the point. 1.35. What is the ratio of the Oil Rent (as % of GDP) in Uzbekistan in 2006 to that in 2011?
Your answer should be compact. 2.6. What is the ratio of the Oil Rent (as % of GDP) in Ecuador in 2007 to that in 2008?
Offer a terse response. 0.89. What is the ratio of the Oil Rent (as % of GDP) in Gabon in 2007 to that in 2008?
Provide a succinct answer. 0.93. What is the ratio of the Oil Rent (as % of GDP) in Norway in 2007 to that in 2008?
Offer a terse response. 0.87. What is the ratio of the Oil Rent (as % of GDP) of Uzbekistan in 2007 to that in 2008?
Offer a very short reply. 0.92. What is the ratio of the Oil Rent (as % of GDP) of Ecuador in 2007 to that in 2009?
Provide a succinct answer. 1.64. What is the ratio of the Oil Rent (as % of GDP) of Gabon in 2007 to that in 2009?
Offer a very short reply. 1.24. What is the ratio of the Oil Rent (as % of GDP) of Norway in 2007 to that in 2009?
Offer a very short reply. 1.36. What is the ratio of the Oil Rent (as % of GDP) of Uzbekistan in 2007 to that in 2009?
Your answer should be very brief. 2.07. What is the ratio of the Oil Rent (as % of GDP) of Ecuador in 2007 to that in 2010?
Provide a succinct answer. 1.38. What is the ratio of the Oil Rent (as % of GDP) of Gabon in 2007 to that in 2010?
Keep it short and to the point. 1.07. What is the ratio of the Oil Rent (as % of GDP) in Norway in 2007 to that in 2010?
Ensure brevity in your answer.  1.26. What is the ratio of the Oil Rent (as % of GDP) of Uzbekistan in 2007 to that in 2010?
Give a very brief answer. 2.29. What is the ratio of the Oil Rent (as % of GDP) of Gabon in 2007 to that in 2011?
Ensure brevity in your answer.  0.99. What is the ratio of the Oil Rent (as % of GDP) in Norway in 2007 to that in 2011?
Offer a terse response. 1.16. What is the ratio of the Oil Rent (as % of GDP) in Uzbekistan in 2007 to that in 2011?
Ensure brevity in your answer.  1.99. What is the ratio of the Oil Rent (as % of GDP) in Ecuador in 2008 to that in 2009?
Your answer should be compact. 1.85. What is the ratio of the Oil Rent (as % of GDP) of Gabon in 2008 to that in 2009?
Your answer should be compact. 1.34. What is the ratio of the Oil Rent (as % of GDP) in Norway in 2008 to that in 2009?
Give a very brief answer. 1.57. What is the ratio of the Oil Rent (as % of GDP) of Uzbekistan in 2008 to that in 2009?
Your answer should be very brief. 2.24. What is the ratio of the Oil Rent (as % of GDP) in Ecuador in 2008 to that in 2010?
Keep it short and to the point. 1.56. What is the ratio of the Oil Rent (as % of GDP) in Gabon in 2008 to that in 2010?
Give a very brief answer. 1.15. What is the ratio of the Oil Rent (as % of GDP) in Norway in 2008 to that in 2010?
Provide a short and direct response. 1.45. What is the ratio of the Oil Rent (as % of GDP) of Uzbekistan in 2008 to that in 2010?
Give a very brief answer. 2.48. What is the ratio of the Oil Rent (as % of GDP) of Ecuador in 2008 to that in 2011?
Your answer should be very brief. 1.29. What is the ratio of the Oil Rent (as % of GDP) of Gabon in 2008 to that in 2011?
Keep it short and to the point. 1.07. What is the ratio of the Oil Rent (as % of GDP) in Norway in 2008 to that in 2011?
Provide a succinct answer. 1.34. What is the ratio of the Oil Rent (as % of GDP) in Uzbekistan in 2008 to that in 2011?
Offer a terse response. 2.16. What is the ratio of the Oil Rent (as % of GDP) in Ecuador in 2009 to that in 2010?
Provide a short and direct response. 0.84. What is the ratio of the Oil Rent (as % of GDP) of Gabon in 2009 to that in 2010?
Ensure brevity in your answer.  0.86. What is the ratio of the Oil Rent (as % of GDP) in Norway in 2009 to that in 2010?
Give a very brief answer. 0.92. What is the ratio of the Oil Rent (as % of GDP) in Uzbekistan in 2009 to that in 2010?
Provide a succinct answer. 1.11. What is the ratio of the Oil Rent (as % of GDP) of Ecuador in 2009 to that in 2011?
Offer a very short reply. 0.69. What is the ratio of the Oil Rent (as % of GDP) of Gabon in 2009 to that in 2011?
Ensure brevity in your answer.  0.79. What is the ratio of the Oil Rent (as % of GDP) of Norway in 2009 to that in 2011?
Your answer should be very brief. 0.85. What is the ratio of the Oil Rent (as % of GDP) of Uzbekistan in 2009 to that in 2011?
Provide a short and direct response. 0.96. What is the ratio of the Oil Rent (as % of GDP) in Ecuador in 2010 to that in 2011?
Give a very brief answer. 0.83. What is the ratio of the Oil Rent (as % of GDP) in Gabon in 2010 to that in 2011?
Provide a short and direct response. 0.93. What is the ratio of the Oil Rent (as % of GDP) of Norway in 2010 to that in 2011?
Your answer should be compact. 0.92. What is the ratio of the Oil Rent (as % of GDP) in Uzbekistan in 2010 to that in 2011?
Provide a short and direct response. 0.87. What is the difference between the highest and the second highest Oil Rent (as % of GDP) of Ecuador?
Offer a very short reply. 1.98. What is the difference between the highest and the second highest Oil Rent (as % of GDP) of Gabon?
Keep it short and to the point. 0.71. What is the difference between the highest and the second highest Oil Rent (as % of GDP) of Norway?
Your response must be concise. 0.06. What is the difference between the highest and the second highest Oil Rent (as % of GDP) of Uzbekistan?
Give a very brief answer. 0.43. What is the difference between the highest and the lowest Oil Rent (as % of GDP) of Ecuador?
Provide a succinct answer. 11.65. What is the difference between the highest and the lowest Oil Rent (as % of GDP) in Gabon?
Your response must be concise. 13.29. What is the difference between the highest and the lowest Oil Rent (as % of GDP) in Norway?
Provide a short and direct response. 5.33. What is the difference between the highest and the lowest Oil Rent (as % of GDP) in Uzbekistan?
Ensure brevity in your answer.  8.98. 